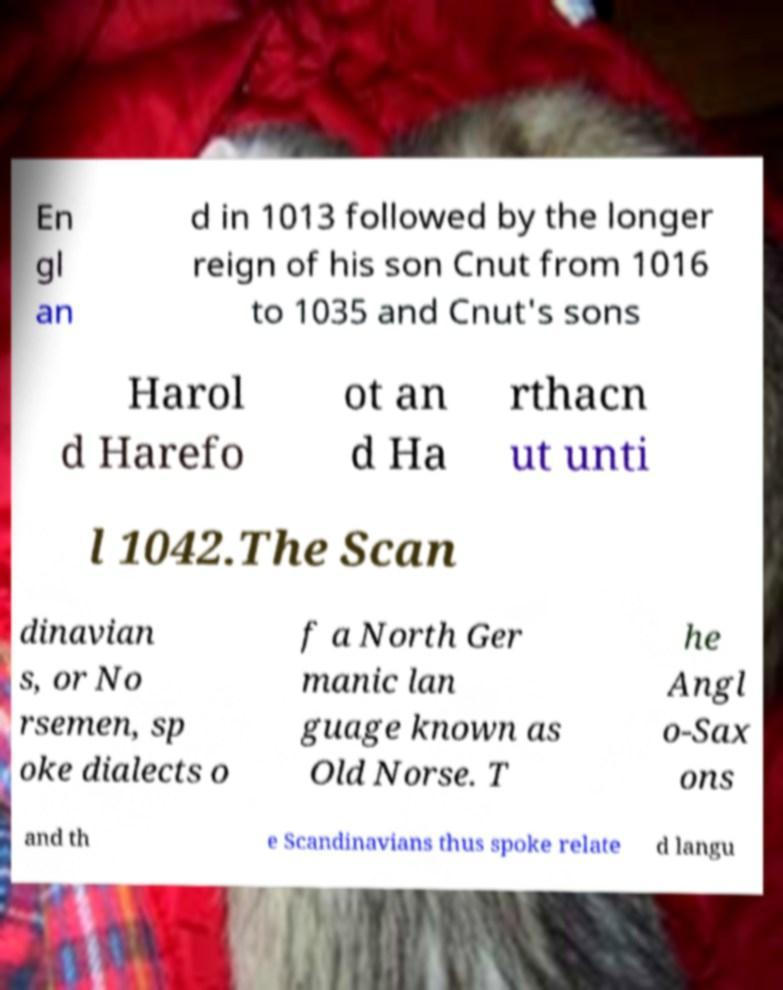Can you read and provide the text displayed in the image?This photo seems to have some interesting text. Can you extract and type it out for me? En gl an d in 1013 followed by the longer reign of his son Cnut from 1016 to 1035 and Cnut's sons Harol d Harefo ot an d Ha rthacn ut unti l 1042.The Scan dinavian s, or No rsemen, sp oke dialects o f a North Ger manic lan guage known as Old Norse. T he Angl o-Sax ons and th e Scandinavians thus spoke relate d langu 